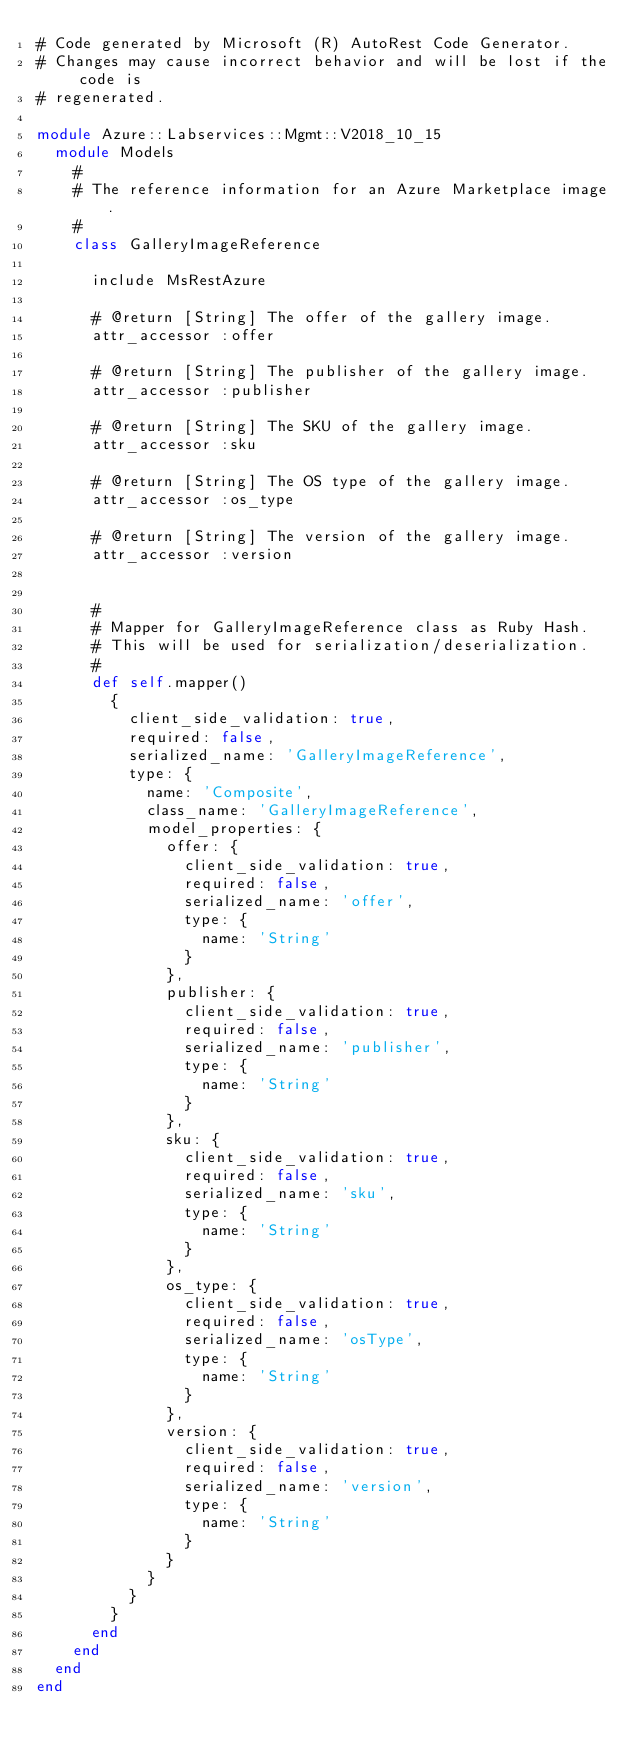<code> <loc_0><loc_0><loc_500><loc_500><_Ruby_># Code generated by Microsoft (R) AutoRest Code Generator.
# Changes may cause incorrect behavior and will be lost if the code is
# regenerated.

module Azure::Labservices::Mgmt::V2018_10_15
  module Models
    #
    # The reference information for an Azure Marketplace image.
    #
    class GalleryImageReference

      include MsRestAzure

      # @return [String] The offer of the gallery image.
      attr_accessor :offer

      # @return [String] The publisher of the gallery image.
      attr_accessor :publisher

      # @return [String] The SKU of the gallery image.
      attr_accessor :sku

      # @return [String] The OS type of the gallery image.
      attr_accessor :os_type

      # @return [String] The version of the gallery image.
      attr_accessor :version


      #
      # Mapper for GalleryImageReference class as Ruby Hash.
      # This will be used for serialization/deserialization.
      #
      def self.mapper()
        {
          client_side_validation: true,
          required: false,
          serialized_name: 'GalleryImageReference',
          type: {
            name: 'Composite',
            class_name: 'GalleryImageReference',
            model_properties: {
              offer: {
                client_side_validation: true,
                required: false,
                serialized_name: 'offer',
                type: {
                  name: 'String'
                }
              },
              publisher: {
                client_side_validation: true,
                required: false,
                serialized_name: 'publisher',
                type: {
                  name: 'String'
                }
              },
              sku: {
                client_side_validation: true,
                required: false,
                serialized_name: 'sku',
                type: {
                  name: 'String'
                }
              },
              os_type: {
                client_side_validation: true,
                required: false,
                serialized_name: 'osType',
                type: {
                  name: 'String'
                }
              },
              version: {
                client_side_validation: true,
                required: false,
                serialized_name: 'version',
                type: {
                  name: 'String'
                }
              }
            }
          }
        }
      end
    end
  end
end
</code> 